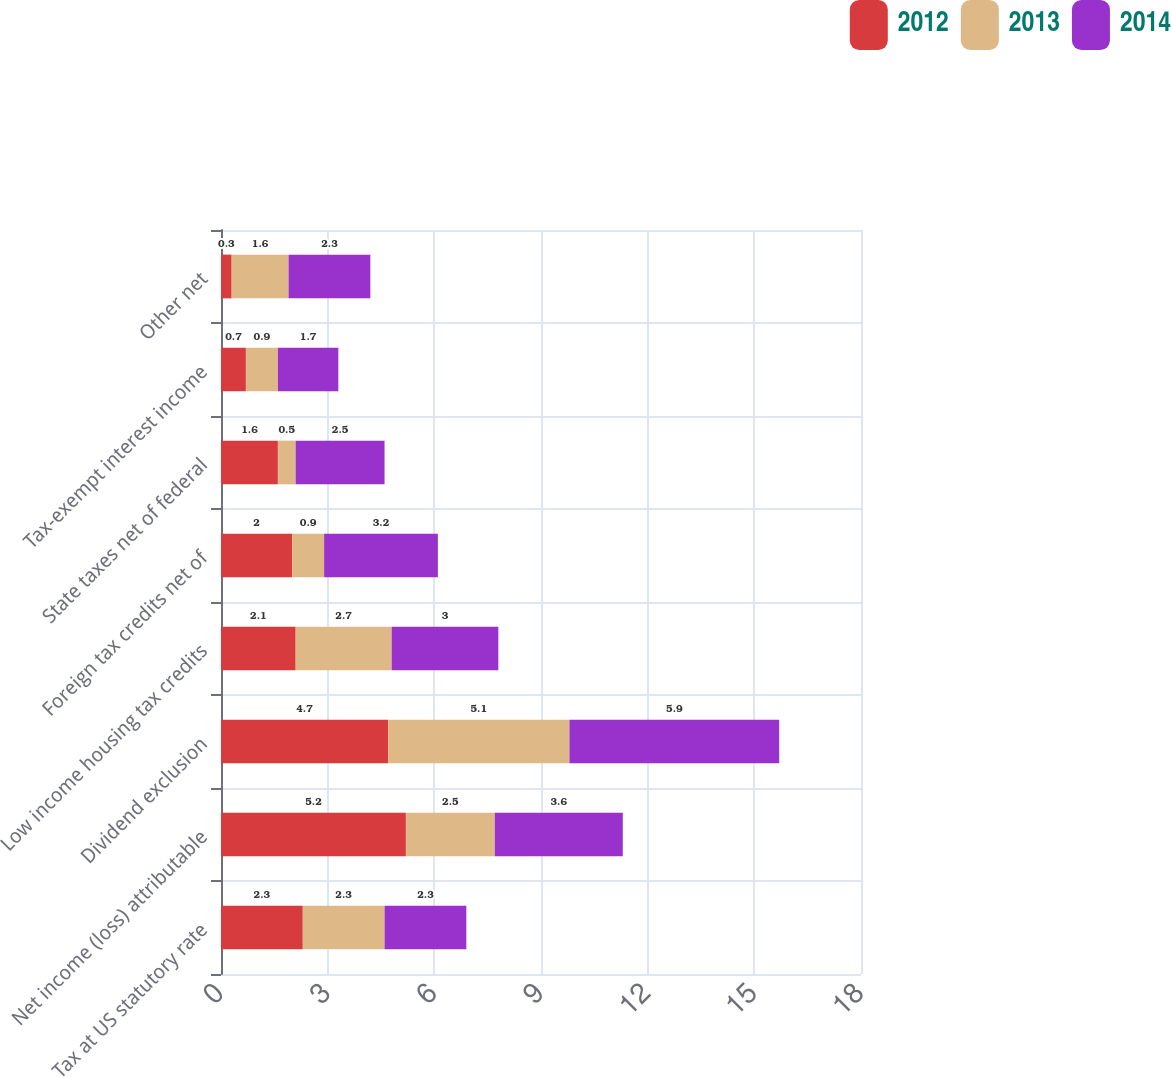<chart> <loc_0><loc_0><loc_500><loc_500><stacked_bar_chart><ecel><fcel>Tax at US statutory rate<fcel>Net income (loss) attributable<fcel>Dividend exclusion<fcel>Low income housing tax credits<fcel>Foreign tax credits net of<fcel>State taxes net of federal<fcel>Tax-exempt interest income<fcel>Other net<nl><fcel>2012<fcel>2.3<fcel>5.2<fcel>4.7<fcel>2.1<fcel>2<fcel>1.6<fcel>0.7<fcel>0.3<nl><fcel>2013<fcel>2.3<fcel>2.5<fcel>5.1<fcel>2.7<fcel>0.9<fcel>0.5<fcel>0.9<fcel>1.6<nl><fcel>2014<fcel>2.3<fcel>3.6<fcel>5.9<fcel>3<fcel>3.2<fcel>2.5<fcel>1.7<fcel>2.3<nl></chart> 